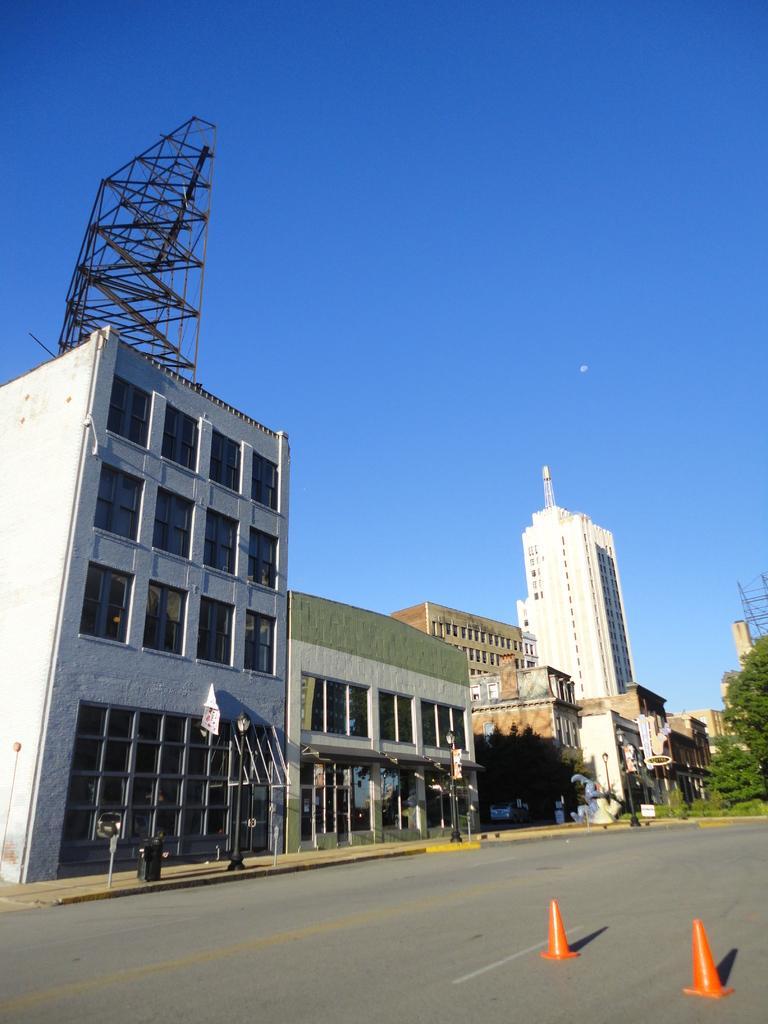In one or two sentences, can you explain what this image depicts? In this image we can see buildings, windows, light poles, there is a dustbin, plants, trees, there are traffic cones, hoarding, also we can see the sky. 